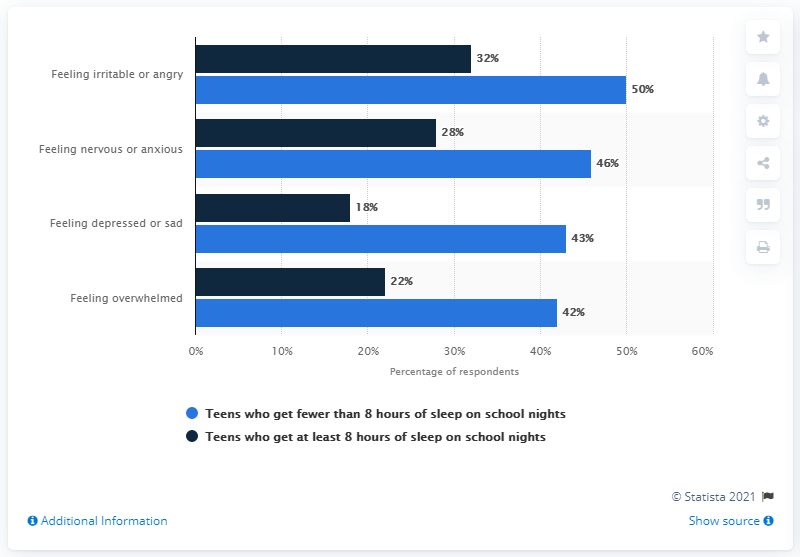Specify some key components in this picture. The sum of the highest and lowest values of the light blue bar is 92. The highest percentage in the light blue bar is 50%. 